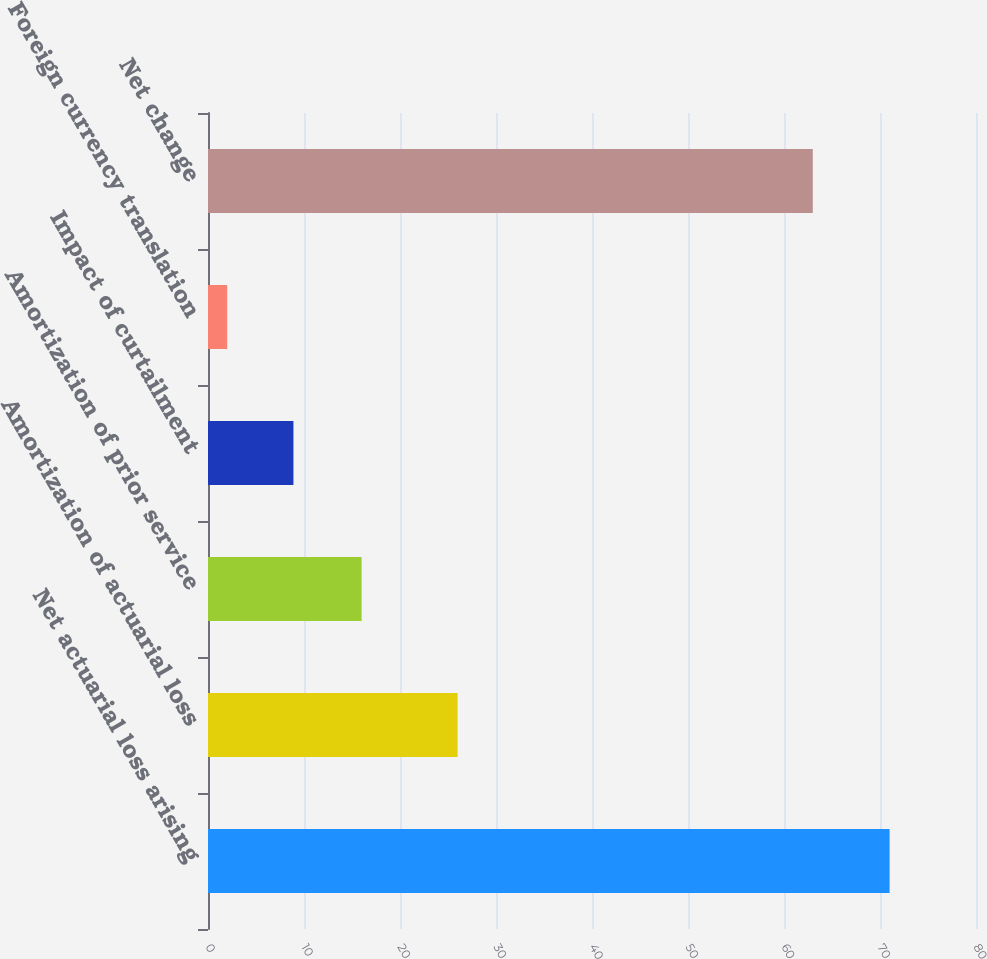<chart> <loc_0><loc_0><loc_500><loc_500><bar_chart><fcel>Net actuarial loss arising<fcel>Amortization of actuarial loss<fcel>Amortization of prior service<fcel>Impact of curtailment<fcel>Foreign currency translation<fcel>Net change<nl><fcel>71<fcel>26<fcel>16<fcel>8.9<fcel>2<fcel>63<nl></chart> 